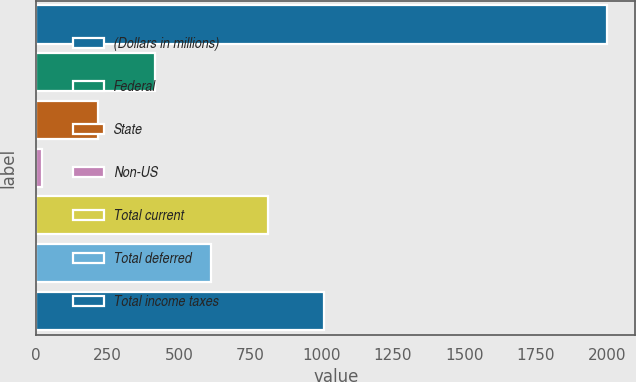Convert chart to OTSL. <chart><loc_0><loc_0><loc_500><loc_500><bar_chart><fcel>(Dollars in millions)<fcel>Federal<fcel>State<fcel>Non-US<fcel>Total current<fcel>Total deferred<fcel>Total income taxes<nl><fcel>1999<fcel>415.8<fcel>217.9<fcel>20<fcel>811.6<fcel>613.7<fcel>1009.5<nl></chart> 